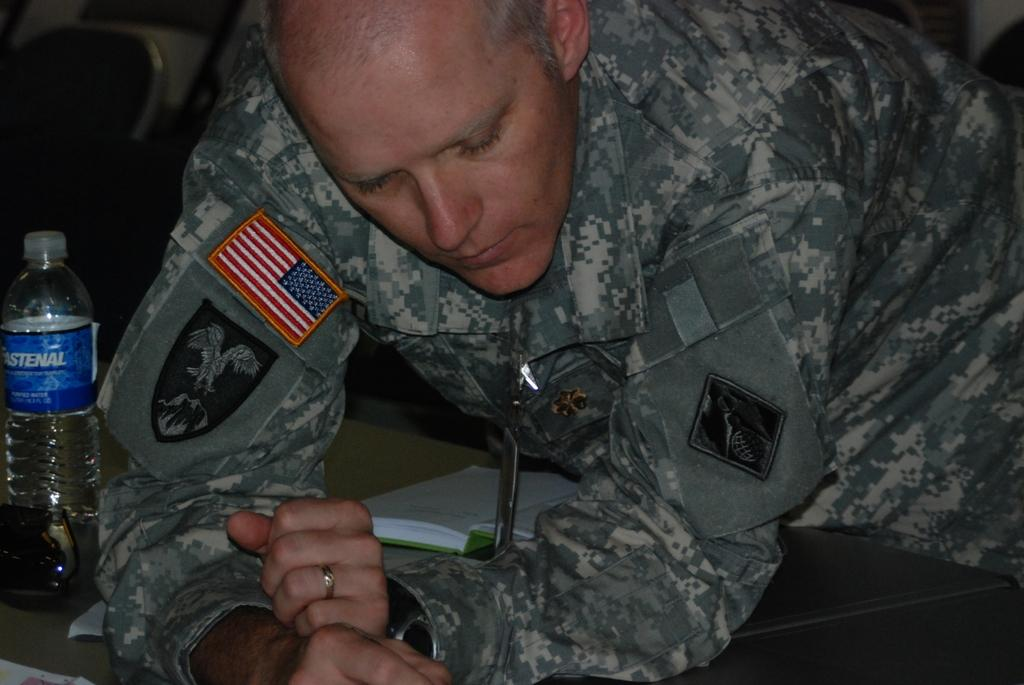Who or what is in the image? There is a person in the image. What is the person doing in the image? The person is leaning on a table. What can be seen on the left side of the image? There is a water bottle on the left side of the image. What is in the middle of the image? There is a book in the middle of the image. What type of throat is visible in the image? There is no throat visible in the image. Is there a basin present in the image? There is no basin mentioned in the provided facts, so we cannot determine if one is present in the image. 